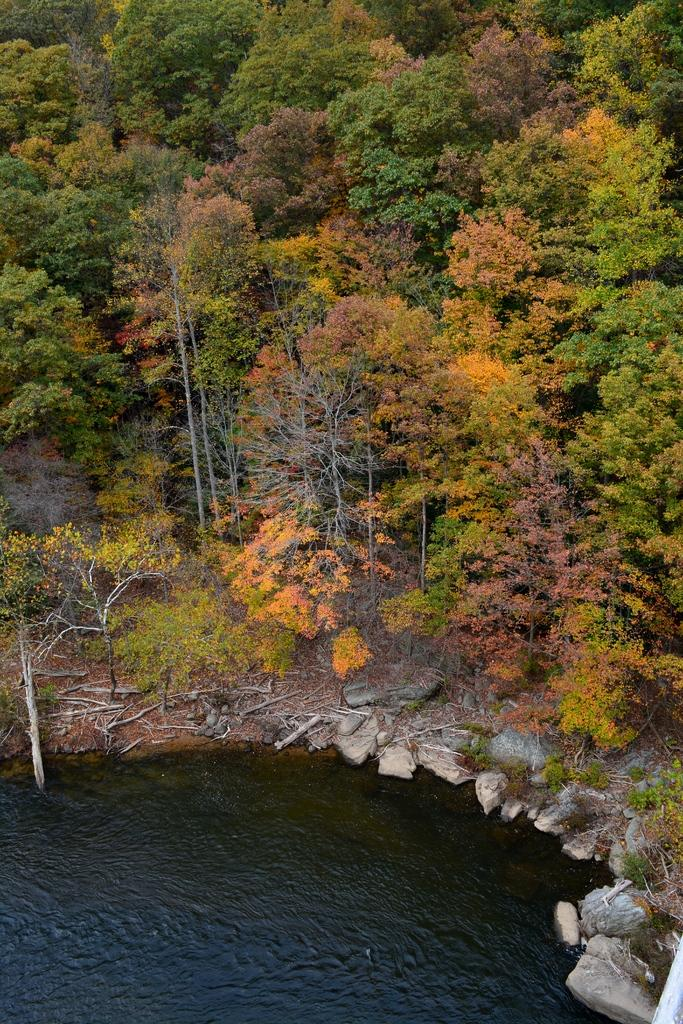What is the primary element visible in the image? There is water in the image. What can be seen near the water? There are rocks near the water. What type of objects are on the land? There are wooden trunks on the land. What is visible in the background of the image? There are trees in the background of the image. What type of account is being discussed in the image? There is no mention of an account in the image; it primarily features water, rocks, wooden trunks, and trees. Is there a road visible in the image? No, there is no road visible in the image. 